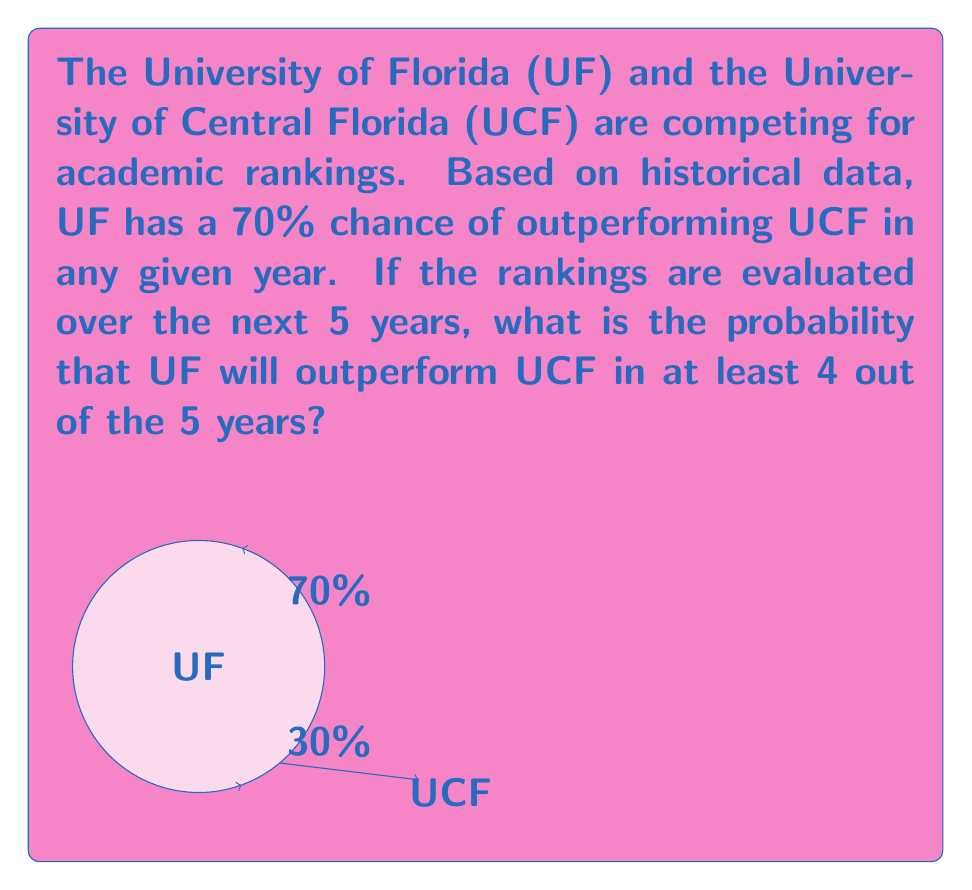Provide a solution to this math problem. Let's approach this step-by-step using the binomial probability formula:

1) Let $X$ be the number of years UF outperforms UCF out of 5 years.

2) We want to find $P(X \geq 4)$, which is equivalent to $P(X = 4) + P(X = 5)$.

3) The probability of success (UF outperforming UCF) in any given year is $p = 0.7$.

4) We can use the binomial probability formula:

   $P(X = k) = \binom{n}{k} p^k (1-p)^{n-k}$

   where $n = 5$ (total number of years) and $k$ is the number of successes.

5) For $k = 4$:
   $P(X = 4) = \binom{5}{4} (0.7)^4 (0.3)^1$
   $= 5 \cdot 0.7^4 \cdot 0.3 = 5 \cdot 0.2401 \cdot 0.3 = 0.36015$

6) For $k = 5$:
   $P(X = 5) = \binom{5}{5} (0.7)^5 (0.3)^0$
   $= 1 \cdot 0.7^5 = 0.16807$

7) Therefore, $P(X \geq 4) = P(X = 4) + P(X = 5)$
   $= 0.36015 + 0.16807 = 0.52822$

Thus, the probability that UF will outperform UCF in at least 4 out of 5 years is approximately 0.52822 or 52.822%.
Answer: $0.52822$ or $52.822\%$ 